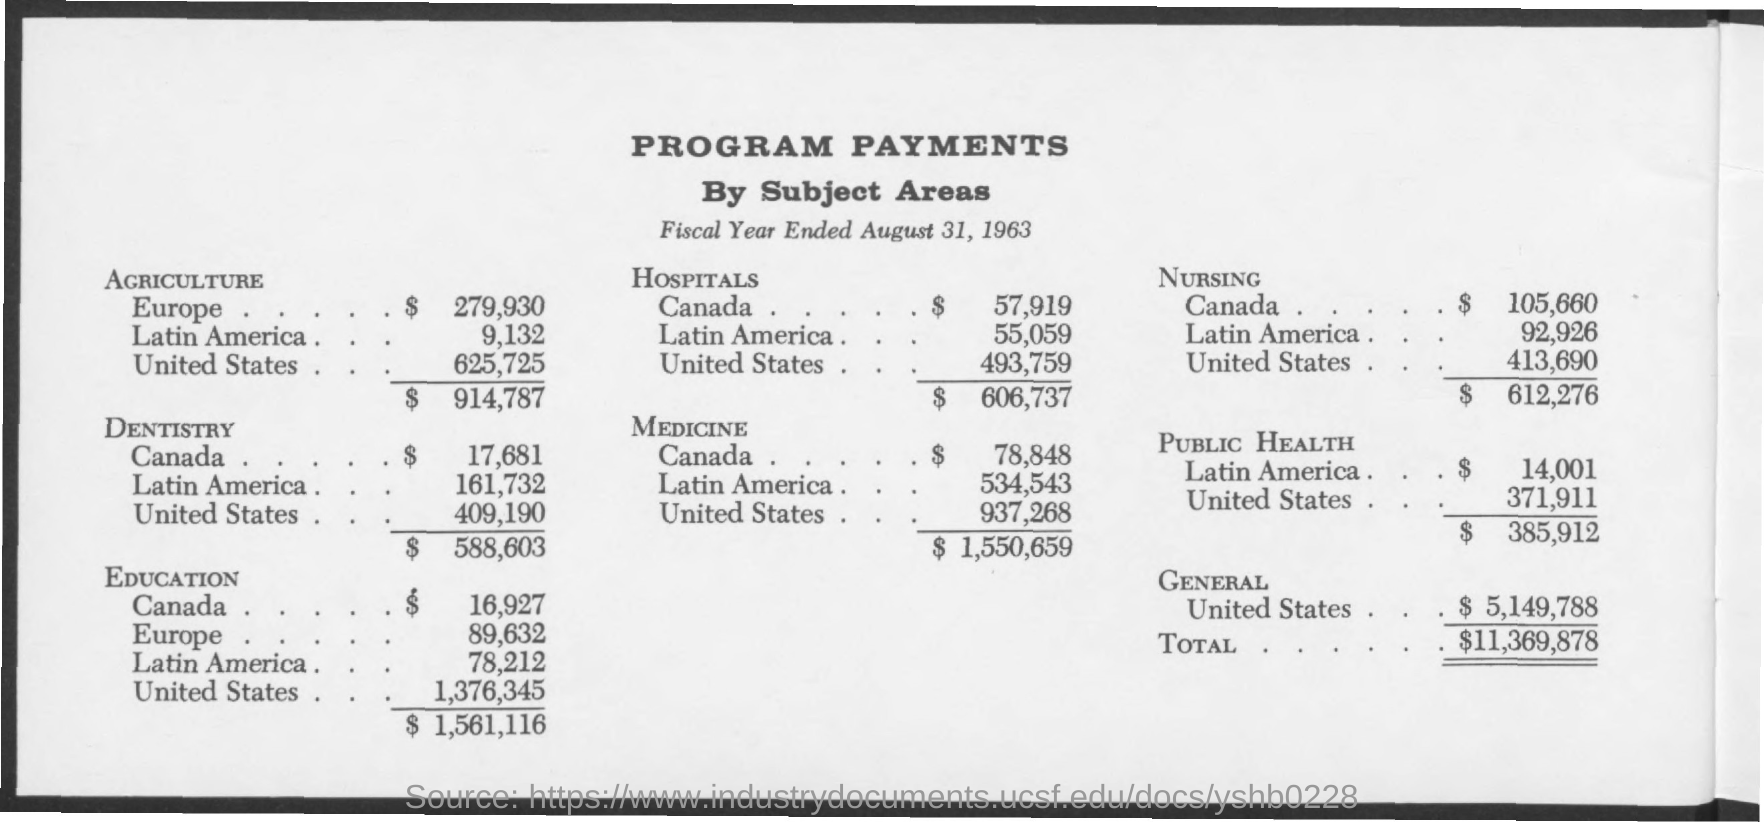What is the Title of the document?
Provide a short and direct response. Program Payments. What is the Program payment for agriculture in Europe?
Your answer should be compact. $ 279,930. What is the Program payment for agriculture in Latin America?
Provide a short and direct response. 9,132. What is the Program payment for agriculture in United States?
Ensure brevity in your answer.  625,725. What is the Total for Agriculture?
Ensure brevity in your answer.  $914,787. What is the Program payment for Dentistry in Canada?
Give a very brief answer. $17,681. What is the Program payment for Dentistry in Latin America?
Your response must be concise. 161,732. What is the Program payment for Dentistry in United States?
Offer a terse response. 409,190. Which is the most expensive program in United States?
Your answer should be very brief. Education. Which is the most expensive program in Canada?
Your answer should be very brief. Nursing. 